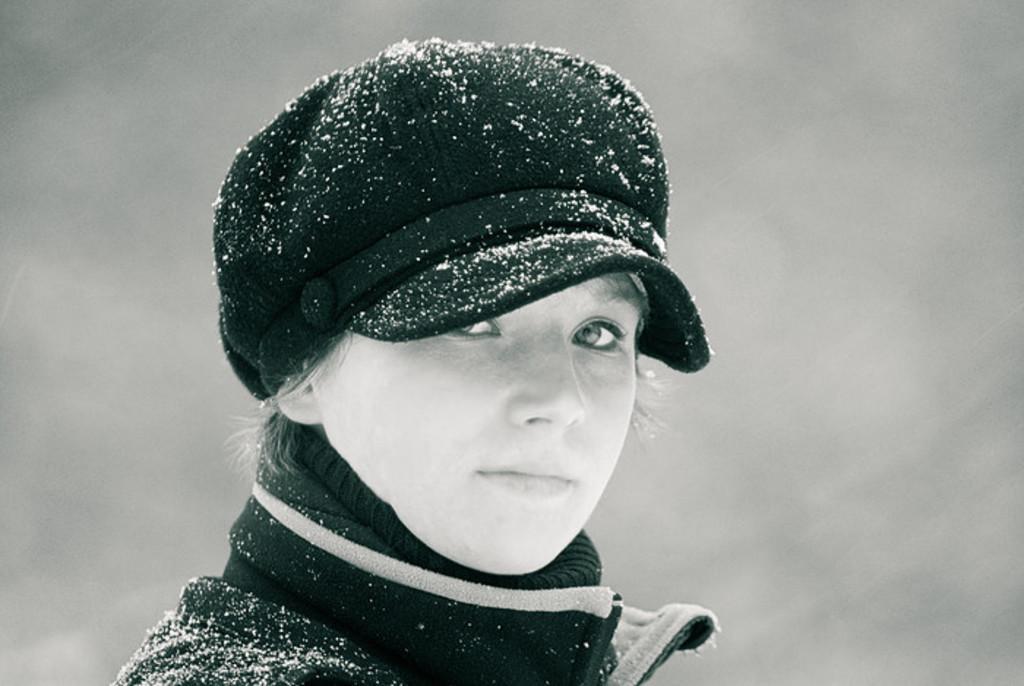How would you summarize this image in a sentence or two? In the image there is a woman, she is wearing a jacket and a hat, there are some snow particles on the hat and jacket. 